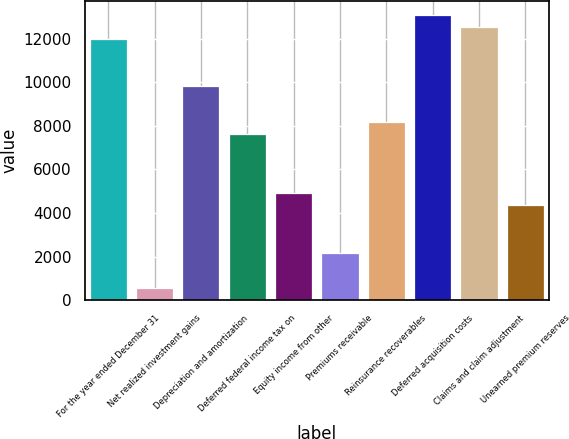Convert chart. <chart><loc_0><loc_0><loc_500><loc_500><bar_chart><fcel>For the year ended December 31<fcel>Net realized investment gains<fcel>Depreciation and amortization<fcel>Deferred federal income tax on<fcel>Equity income from other<fcel>Premiums receivable<fcel>Reinsurance recoverables<fcel>Deferred acquisition costs<fcel>Claims and claim adjustment<fcel>Unearned premium reserves<nl><fcel>11995<fcel>550<fcel>9815<fcel>7635<fcel>4910<fcel>2185<fcel>8180<fcel>13085<fcel>12540<fcel>4365<nl></chart> 